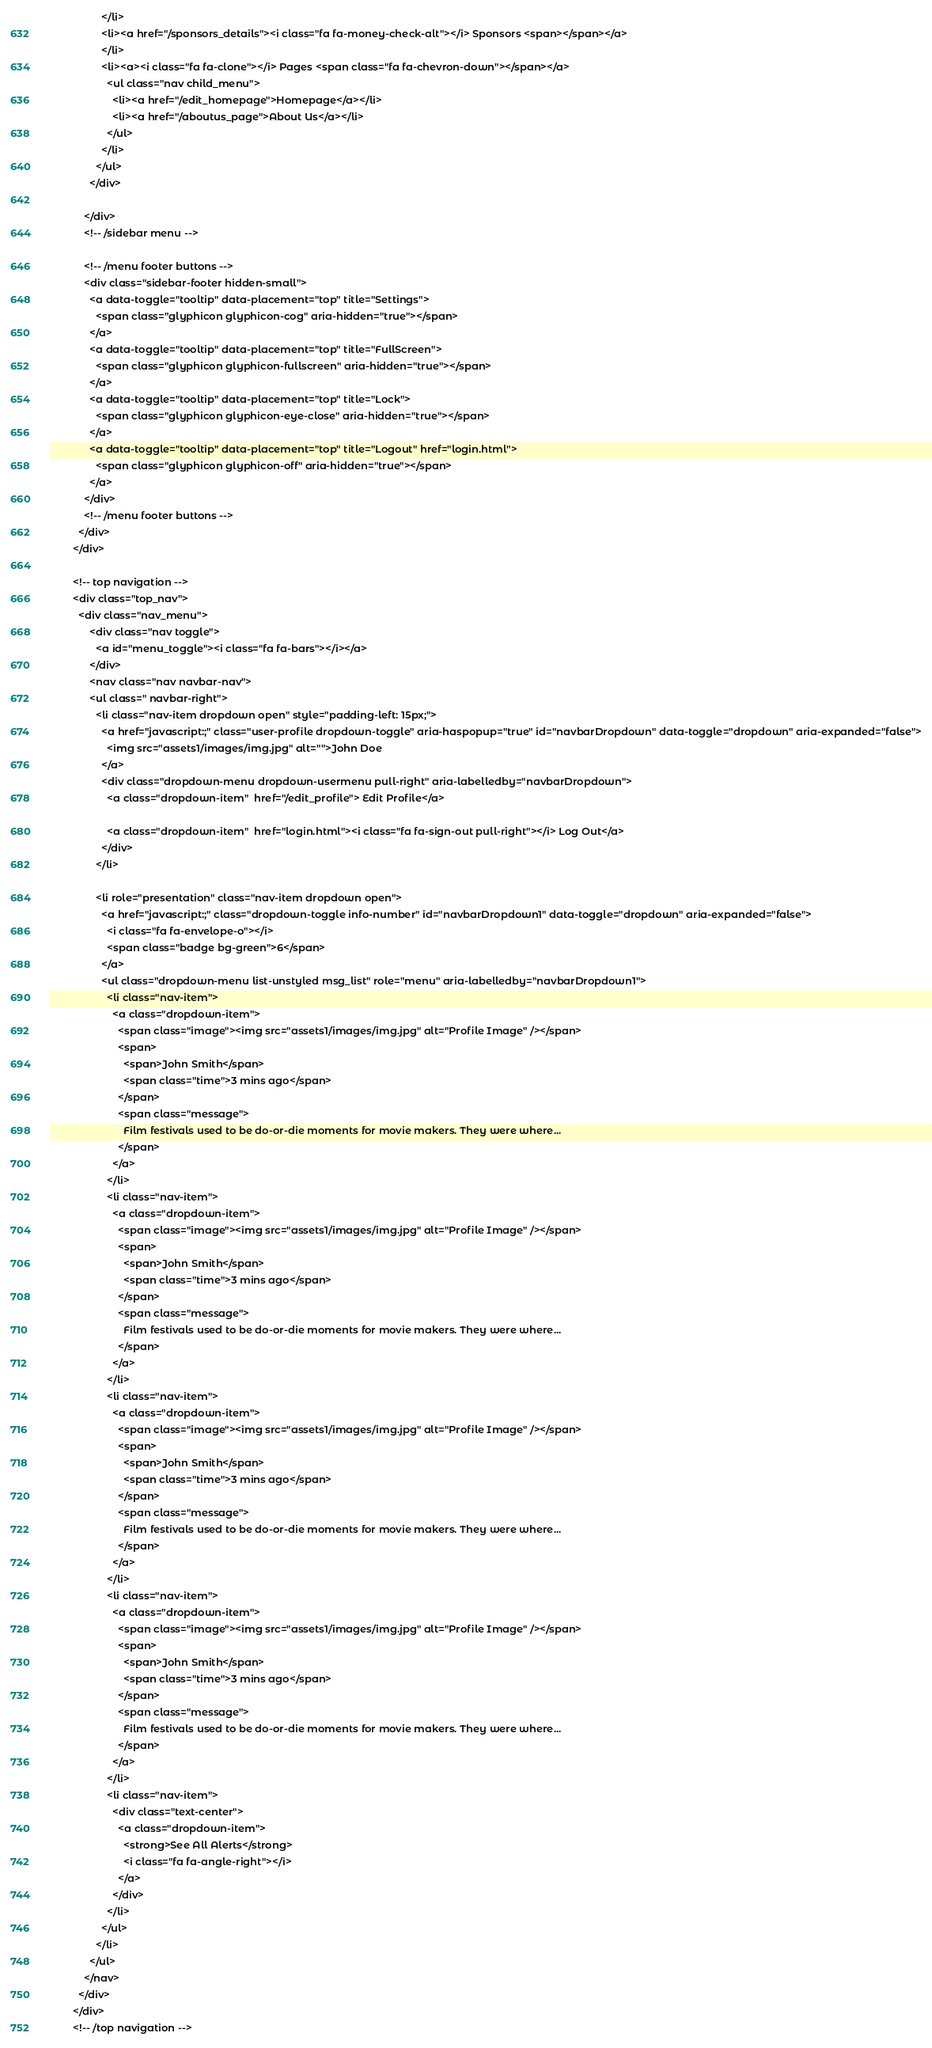<code> <loc_0><loc_0><loc_500><loc_500><_PHP_>                  </li>
                  <li><a href="/sponsors_details"><i class="fa fa-money-check-alt"></i> Sponsors <span></span></a>
                  </li>
                  <li><a><i class="fa fa-clone"></i> Pages <span class="fa fa-chevron-down"></span></a>
                    <ul class="nav child_menu">
                      <li><a href="/edit_homepage">Homepage</a></li>
                      <li><a href="/aboutus_page">About Us</a></li>
                    </ul>
                  </li>
                </ul>
              </div>

            </div>
            <!-- /sidebar menu -->

            <!-- /menu footer buttons -->
            <div class="sidebar-footer hidden-small">
              <a data-toggle="tooltip" data-placement="top" title="Settings">
                <span class="glyphicon glyphicon-cog" aria-hidden="true"></span>
              </a>
              <a data-toggle="tooltip" data-placement="top" title="FullScreen">
                <span class="glyphicon glyphicon-fullscreen" aria-hidden="true"></span>
              </a>
              <a data-toggle="tooltip" data-placement="top" title="Lock">
                <span class="glyphicon glyphicon-eye-close" aria-hidden="true"></span>
              </a>
              <a data-toggle="tooltip" data-placement="top" title="Logout" href="login.html">
                <span class="glyphicon glyphicon-off" aria-hidden="true"></span>
              </a>
            </div>
            <!-- /menu footer buttons -->
          </div>
        </div>

        <!-- top navigation -->
        <div class="top_nav">
          <div class="nav_menu">
              <div class="nav toggle">
                <a id="menu_toggle"><i class="fa fa-bars"></i></a>
              </div>
              <nav class="nav navbar-nav">
              <ul class=" navbar-right">
                <li class="nav-item dropdown open" style="padding-left: 15px;">
                  <a href="javascript:;" class="user-profile dropdown-toggle" aria-haspopup="true" id="navbarDropdown" data-toggle="dropdown" aria-expanded="false">
                    <img src="assets1/images/img.jpg" alt="">John Doe
                  </a>
                  <div class="dropdown-menu dropdown-usermenu pull-right" aria-labelledby="navbarDropdown">
                    <a class="dropdown-item"  href="/edit_profile"> Edit Profile</a>
                      
                    <a class="dropdown-item"  href="login.html"><i class="fa fa-sign-out pull-right"></i> Log Out</a>
                  </div>
                </li>

                <li role="presentation" class="nav-item dropdown open">
                  <a href="javascript:;" class="dropdown-toggle info-number" id="navbarDropdown1" data-toggle="dropdown" aria-expanded="false">
                    <i class="fa fa-envelope-o"></i>
                    <span class="badge bg-green">6</span>
                  </a>
                  <ul class="dropdown-menu list-unstyled msg_list" role="menu" aria-labelledby="navbarDropdown1">
                    <li class="nav-item">
                      <a class="dropdown-item">
                        <span class="image"><img src="assets1/images/img.jpg" alt="Profile Image" /></span>
                        <span>
                          <span>John Smith</span>
                          <span class="time">3 mins ago</span>
                        </span>
                        <span class="message">
                          Film festivals used to be do-or-die moments for movie makers. They were where...
                        </span>
                      </a>
                    </li>
                    <li class="nav-item">
                      <a class="dropdown-item">
                        <span class="image"><img src="assets1/images/img.jpg" alt="Profile Image" /></span>
                        <span>
                          <span>John Smith</span>
                          <span class="time">3 mins ago</span>
                        </span>
                        <span class="message">
                          Film festivals used to be do-or-die moments for movie makers. They were where...
                        </span>
                      </a>
                    </li>
                    <li class="nav-item">
                      <a class="dropdown-item">
                        <span class="image"><img src="assets1/images/img.jpg" alt="Profile Image" /></span>
                        <span>
                          <span>John Smith</span>
                          <span class="time">3 mins ago</span>
                        </span>
                        <span class="message">
                          Film festivals used to be do-or-die moments for movie makers. They were where...
                        </span>
                      </a>
                    </li>
                    <li class="nav-item">
                      <a class="dropdown-item">
                        <span class="image"><img src="assets1/images/img.jpg" alt="Profile Image" /></span>
                        <span>
                          <span>John Smith</span>
                          <span class="time">3 mins ago</span>
                        </span>
                        <span class="message">
                          Film festivals used to be do-or-die moments for movie makers. They were where...
                        </span>
                      </a>
                    </li>
                    <li class="nav-item">
                      <div class="text-center">
                        <a class="dropdown-item">
                          <strong>See All Alerts</strong>
                          <i class="fa fa-angle-right"></i>
                        </a>
                      </div>
                    </li>
                  </ul>
                </li>
              </ul>
            </nav>
          </div>
        </div>
        <!-- /top navigation --></code> 